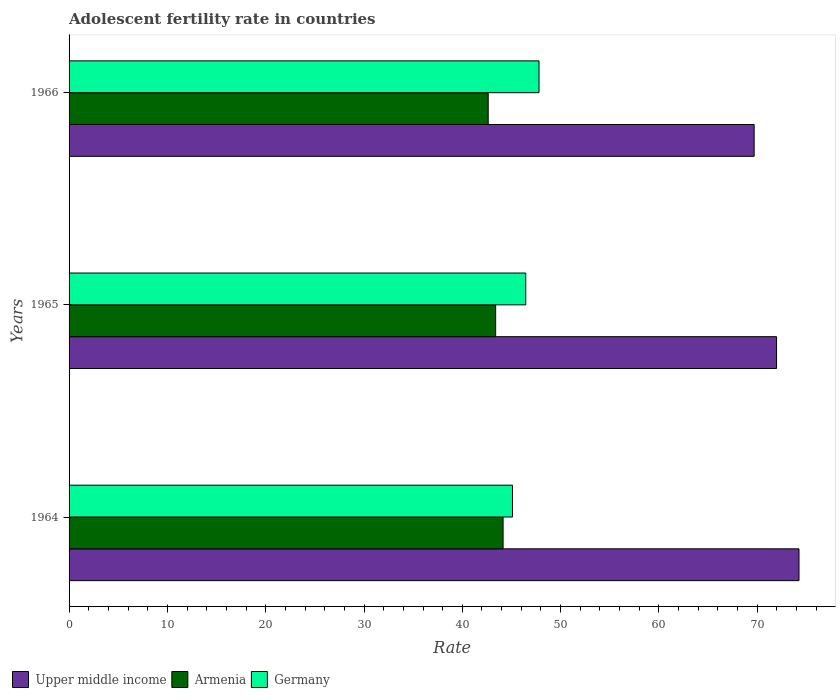How many groups of bars are there?
Offer a very short reply. 3. Are the number of bars per tick equal to the number of legend labels?
Ensure brevity in your answer.  Yes. How many bars are there on the 1st tick from the top?
Your answer should be compact. 3. How many bars are there on the 3rd tick from the bottom?
Ensure brevity in your answer.  3. What is the label of the 3rd group of bars from the top?
Your answer should be very brief. 1964. What is the adolescent fertility rate in Upper middle income in 1964?
Provide a succinct answer. 74.24. Across all years, what is the maximum adolescent fertility rate in Armenia?
Give a very brief answer. 44.15. Across all years, what is the minimum adolescent fertility rate in Germany?
Your response must be concise. 45.1. In which year was the adolescent fertility rate in Armenia maximum?
Offer a terse response. 1964. In which year was the adolescent fertility rate in Upper middle income minimum?
Give a very brief answer. 1966. What is the total adolescent fertility rate in Upper middle income in the graph?
Your answer should be compact. 215.89. What is the difference between the adolescent fertility rate in Armenia in 1964 and that in 1965?
Make the answer very short. 0.76. What is the difference between the adolescent fertility rate in Upper middle income in 1966 and the adolescent fertility rate in Germany in 1964?
Make the answer very short. 24.58. What is the average adolescent fertility rate in Armenia per year?
Your response must be concise. 43.39. In the year 1966, what is the difference between the adolescent fertility rate in Upper middle income and adolescent fertility rate in Armenia?
Ensure brevity in your answer.  27.05. What is the ratio of the adolescent fertility rate in Armenia in 1965 to that in 1966?
Offer a terse response. 1.02. Is the adolescent fertility rate in Germany in 1965 less than that in 1966?
Provide a succinct answer. Yes. What is the difference between the highest and the second highest adolescent fertility rate in Armenia?
Ensure brevity in your answer.  0.76. What is the difference between the highest and the lowest adolescent fertility rate in Armenia?
Ensure brevity in your answer.  1.52. In how many years, is the adolescent fertility rate in Germany greater than the average adolescent fertility rate in Germany taken over all years?
Provide a short and direct response. 1. What does the 2nd bar from the top in 1966 represents?
Keep it short and to the point. Armenia. What does the 3rd bar from the bottom in 1966 represents?
Ensure brevity in your answer.  Germany. Is it the case that in every year, the sum of the adolescent fertility rate in Armenia and adolescent fertility rate in Upper middle income is greater than the adolescent fertility rate in Germany?
Offer a very short reply. Yes. What is the difference between two consecutive major ticks on the X-axis?
Give a very brief answer. 10. Does the graph contain any zero values?
Make the answer very short. No. Does the graph contain grids?
Offer a terse response. No. How are the legend labels stacked?
Provide a succinct answer. Horizontal. What is the title of the graph?
Your answer should be compact. Adolescent fertility rate in countries. Does "South Sudan" appear as one of the legend labels in the graph?
Offer a terse response. No. What is the label or title of the X-axis?
Your answer should be compact. Rate. What is the label or title of the Y-axis?
Give a very brief answer. Years. What is the Rate in Upper middle income in 1964?
Ensure brevity in your answer.  74.24. What is the Rate of Armenia in 1964?
Your answer should be compact. 44.15. What is the Rate of Germany in 1964?
Give a very brief answer. 45.1. What is the Rate in Upper middle income in 1965?
Offer a very short reply. 71.96. What is the Rate in Armenia in 1965?
Keep it short and to the point. 43.39. What is the Rate in Germany in 1965?
Provide a succinct answer. 46.45. What is the Rate of Upper middle income in 1966?
Provide a short and direct response. 69.68. What is the Rate of Armenia in 1966?
Provide a succinct answer. 42.63. What is the Rate of Germany in 1966?
Provide a short and direct response. 47.8. Across all years, what is the maximum Rate in Upper middle income?
Your response must be concise. 74.24. Across all years, what is the maximum Rate in Armenia?
Your answer should be compact. 44.15. Across all years, what is the maximum Rate of Germany?
Offer a very short reply. 47.8. Across all years, what is the minimum Rate of Upper middle income?
Your response must be concise. 69.68. Across all years, what is the minimum Rate of Armenia?
Ensure brevity in your answer.  42.63. Across all years, what is the minimum Rate of Germany?
Keep it short and to the point. 45.1. What is the total Rate in Upper middle income in the graph?
Your answer should be compact. 215.89. What is the total Rate of Armenia in the graph?
Provide a succinct answer. 130.17. What is the total Rate of Germany in the graph?
Make the answer very short. 139.35. What is the difference between the Rate of Upper middle income in 1964 and that in 1965?
Make the answer very short. 2.28. What is the difference between the Rate in Armenia in 1964 and that in 1965?
Provide a succinct answer. 0.76. What is the difference between the Rate of Germany in 1964 and that in 1965?
Your answer should be very brief. -1.35. What is the difference between the Rate in Upper middle income in 1964 and that in 1966?
Offer a terse response. 4.56. What is the difference between the Rate in Armenia in 1964 and that in 1966?
Give a very brief answer. 1.52. What is the difference between the Rate of Germany in 1964 and that in 1966?
Ensure brevity in your answer.  -2.7. What is the difference between the Rate of Upper middle income in 1965 and that in 1966?
Your response must be concise. 2.28. What is the difference between the Rate of Armenia in 1965 and that in 1966?
Offer a very short reply. 0.76. What is the difference between the Rate of Germany in 1965 and that in 1966?
Your answer should be compact. -1.35. What is the difference between the Rate of Upper middle income in 1964 and the Rate of Armenia in 1965?
Offer a very short reply. 30.85. What is the difference between the Rate of Upper middle income in 1964 and the Rate of Germany in 1965?
Your answer should be very brief. 27.79. What is the difference between the Rate of Armenia in 1964 and the Rate of Germany in 1965?
Your answer should be compact. -2.3. What is the difference between the Rate of Upper middle income in 1964 and the Rate of Armenia in 1966?
Your answer should be very brief. 31.61. What is the difference between the Rate of Upper middle income in 1964 and the Rate of Germany in 1966?
Keep it short and to the point. 26.44. What is the difference between the Rate in Armenia in 1964 and the Rate in Germany in 1966?
Provide a short and direct response. -3.65. What is the difference between the Rate in Upper middle income in 1965 and the Rate in Armenia in 1966?
Your answer should be very brief. 29.33. What is the difference between the Rate in Upper middle income in 1965 and the Rate in Germany in 1966?
Offer a very short reply. 24.16. What is the difference between the Rate of Armenia in 1965 and the Rate of Germany in 1966?
Provide a succinct answer. -4.41. What is the average Rate in Upper middle income per year?
Your answer should be very brief. 71.96. What is the average Rate of Armenia per year?
Your answer should be very brief. 43.39. What is the average Rate of Germany per year?
Provide a short and direct response. 46.45. In the year 1964, what is the difference between the Rate in Upper middle income and Rate in Armenia?
Your response must be concise. 30.1. In the year 1964, what is the difference between the Rate in Upper middle income and Rate in Germany?
Offer a terse response. 29.14. In the year 1964, what is the difference between the Rate of Armenia and Rate of Germany?
Ensure brevity in your answer.  -0.95. In the year 1965, what is the difference between the Rate in Upper middle income and Rate in Armenia?
Your response must be concise. 28.57. In the year 1965, what is the difference between the Rate of Upper middle income and Rate of Germany?
Your response must be concise. 25.51. In the year 1965, what is the difference between the Rate in Armenia and Rate in Germany?
Your response must be concise. -3.06. In the year 1966, what is the difference between the Rate in Upper middle income and Rate in Armenia?
Give a very brief answer. 27.05. In the year 1966, what is the difference between the Rate of Upper middle income and Rate of Germany?
Give a very brief answer. 21.88. In the year 1966, what is the difference between the Rate of Armenia and Rate of Germany?
Provide a succinct answer. -5.17. What is the ratio of the Rate of Upper middle income in 1964 to that in 1965?
Provide a succinct answer. 1.03. What is the ratio of the Rate of Armenia in 1964 to that in 1965?
Your answer should be compact. 1.02. What is the ratio of the Rate in Upper middle income in 1964 to that in 1966?
Offer a very short reply. 1.07. What is the ratio of the Rate in Armenia in 1964 to that in 1966?
Provide a succinct answer. 1.04. What is the ratio of the Rate in Germany in 1964 to that in 1966?
Offer a very short reply. 0.94. What is the ratio of the Rate in Upper middle income in 1965 to that in 1966?
Keep it short and to the point. 1.03. What is the ratio of the Rate in Armenia in 1965 to that in 1966?
Your answer should be very brief. 1.02. What is the ratio of the Rate in Germany in 1965 to that in 1966?
Your response must be concise. 0.97. What is the difference between the highest and the second highest Rate in Upper middle income?
Make the answer very short. 2.28. What is the difference between the highest and the second highest Rate of Armenia?
Make the answer very short. 0.76. What is the difference between the highest and the second highest Rate of Germany?
Give a very brief answer. 1.35. What is the difference between the highest and the lowest Rate in Upper middle income?
Offer a terse response. 4.56. What is the difference between the highest and the lowest Rate in Armenia?
Provide a succinct answer. 1.52. What is the difference between the highest and the lowest Rate in Germany?
Offer a very short reply. 2.7. 